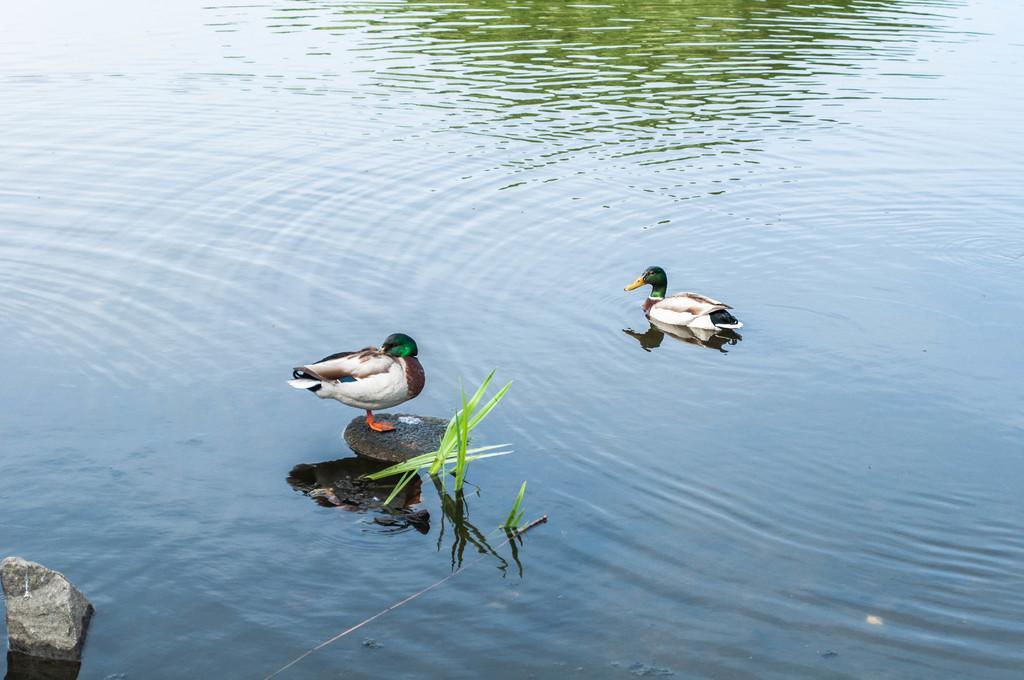In one or two sentences, can you explain what this image depicts? In the image we can see water, in the water we can see some stones and grass. Above the water we can see two ducks. 